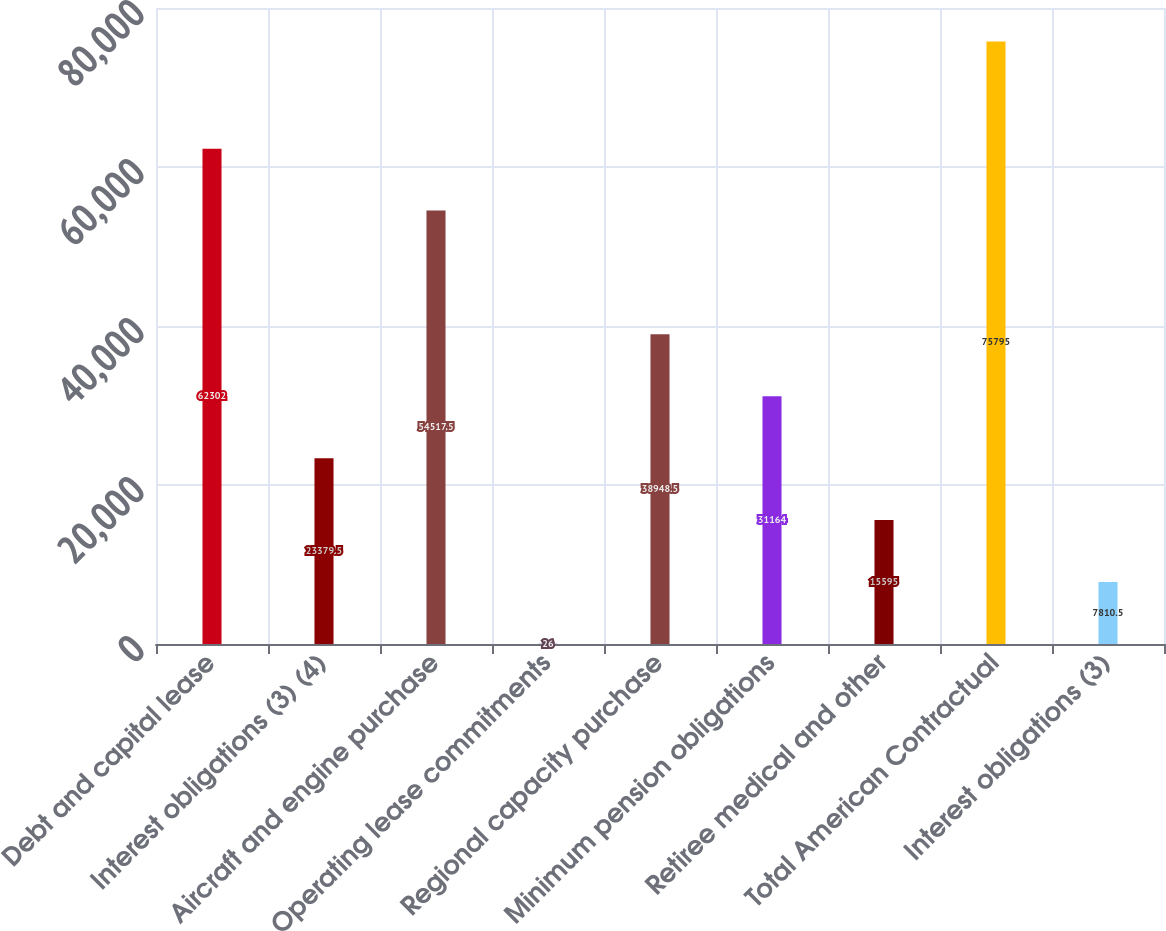<chart> <loc_0><loc_0><loc_500><loc_500><bar_chart><fcel>Debt and capital lease<fcel>Interest obligations (3) (4)<fcel>Aircraft and engine purchase<fcel>Operating lease commitments<fcel>Regional capacity purchase<fcel>Minimum pension obligations<fcel>Retiree medical and other<fcel>Total American Contractual<fcel>Interest obligations (3)<nl><fcel>62302<fcel>23379.5<fcel>54517.5<fcel>26<fcel>38948.5<fcel>31164<fcel>15595<fcel>75795<fcel>7810.5<nl></chart> 